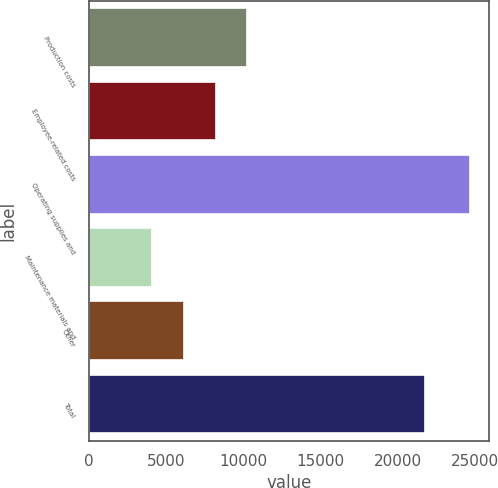Convert chart to OTSL. <chart><loc_0><loc_0><loc_500><loc_500><bar_chart><fcel>Production costs<fcel>Employee-related costs<fcel>Operating supplies and<fcel>Maintenance materials and<fcel>Other<fcel>Total<nl><fcel>10246.6<fcel>8192.4<fcel>24626<fcel>4084<fcel>6138.2<fcel>21742<nl></chart> 